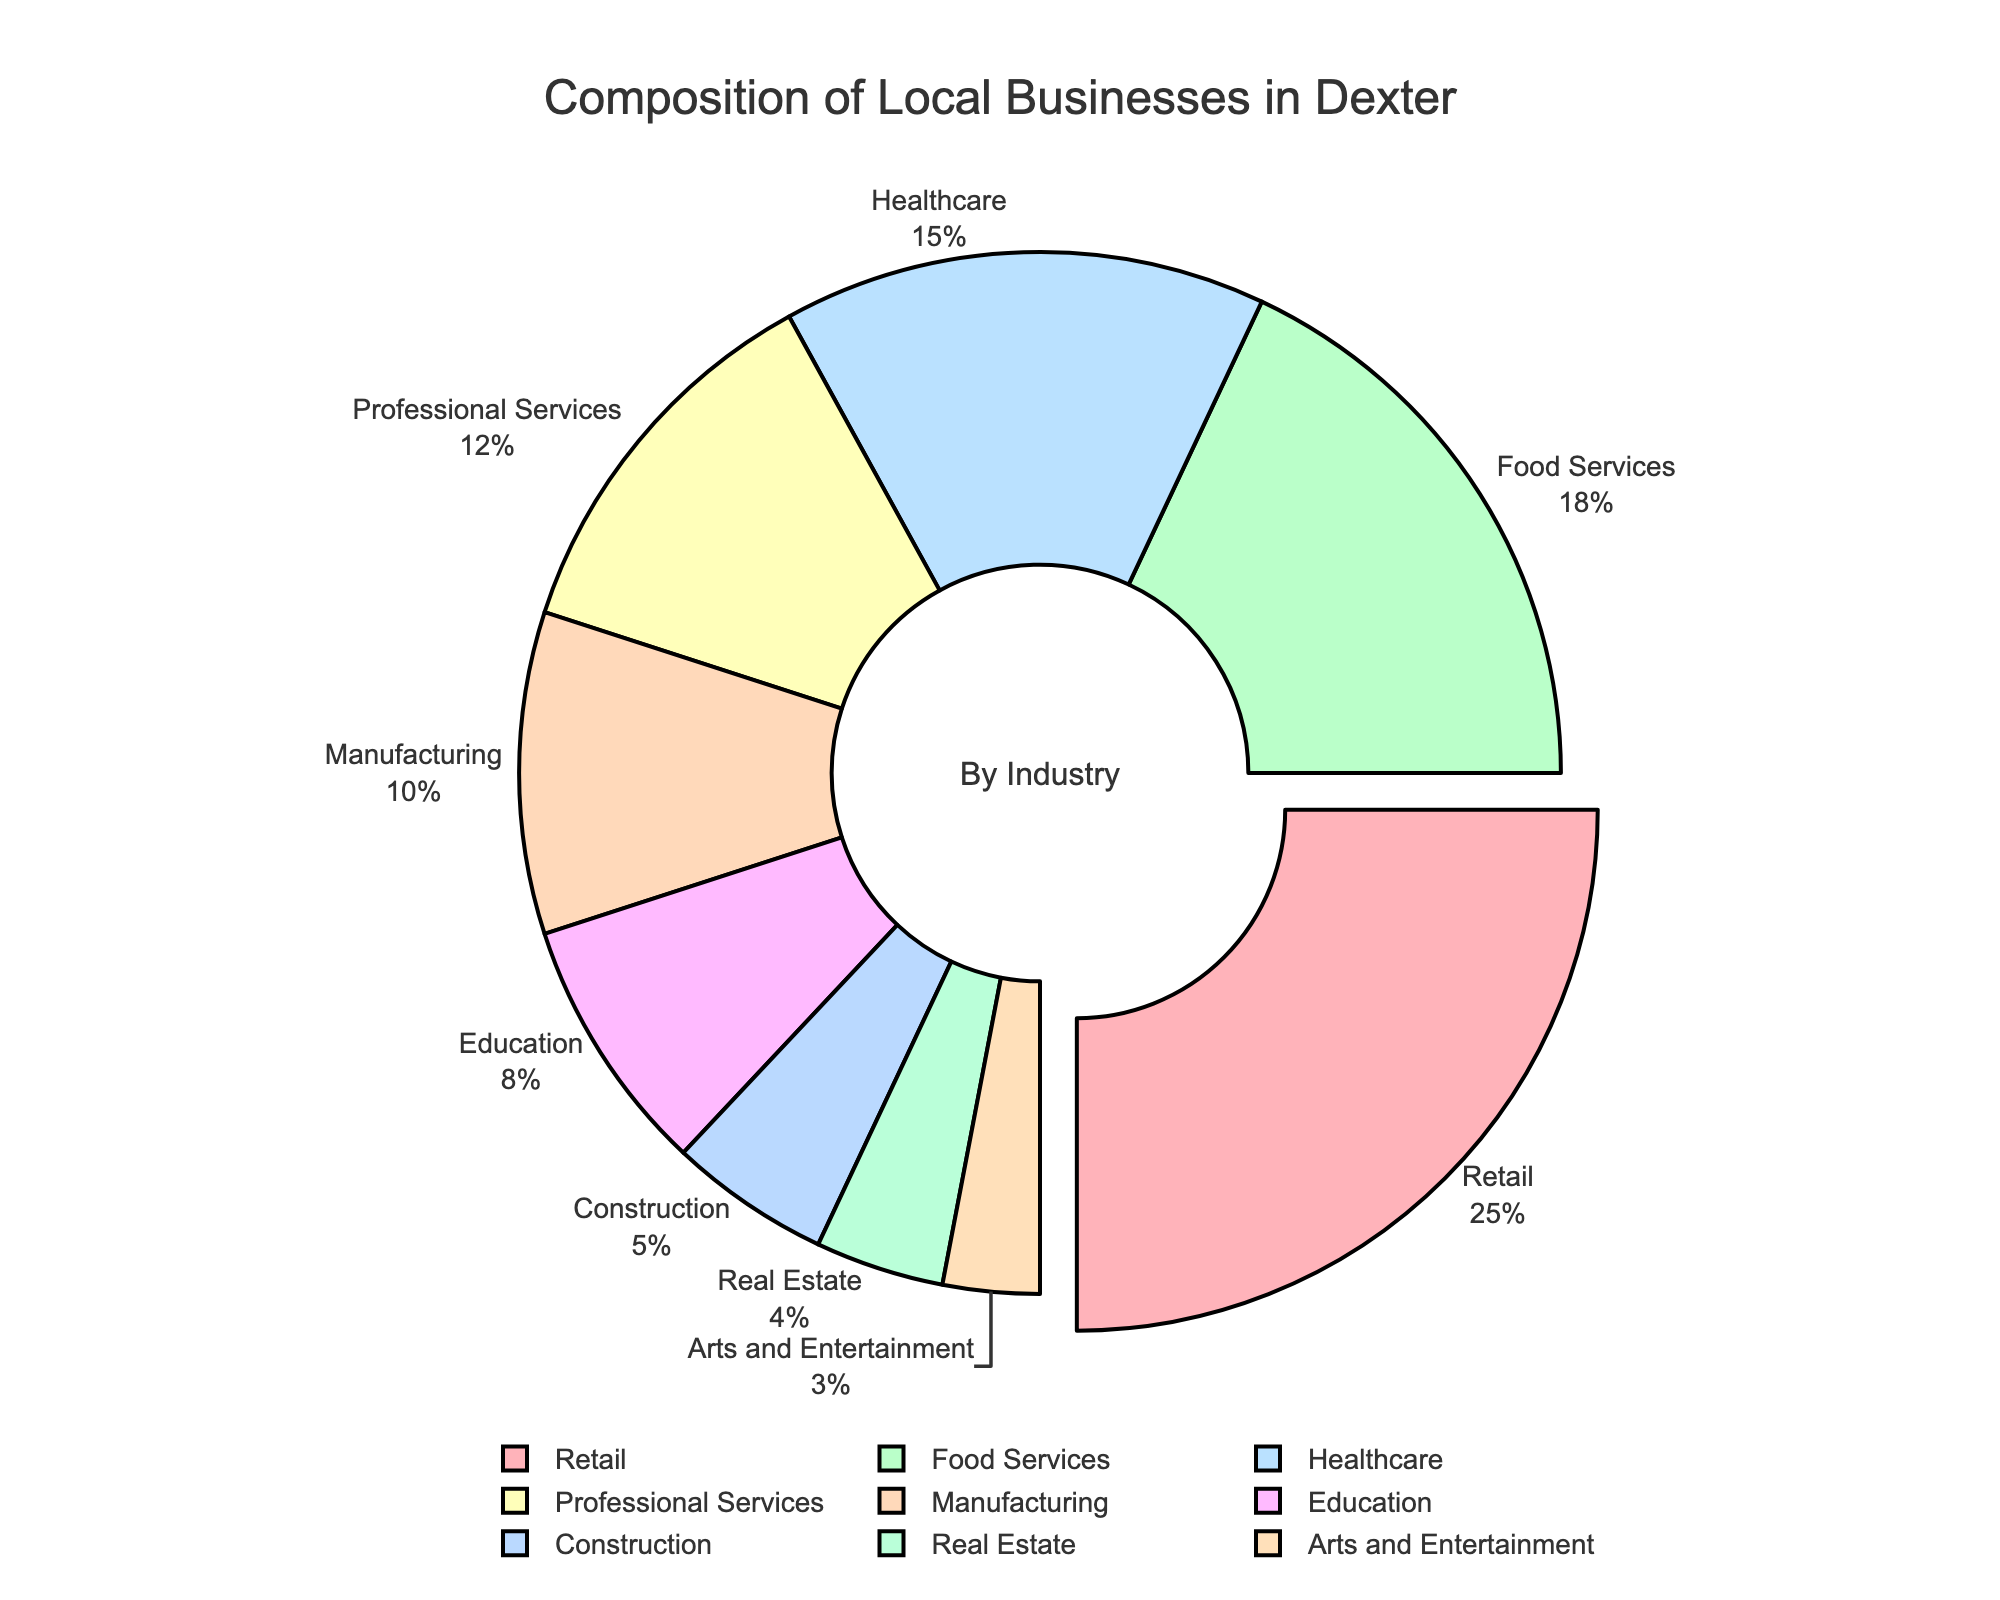What percentage of local businesses in Dexter are in the Retail and Food Services industries combined? Look at the sections of the pie chart labeled "Retail" and "Food Services". The Retail industry makes up 25% of local businesses, and the Food Services industry makes up 18%. Add these percentages together: 25% + 18% = 43%.
Answer: 43% Which industry has the smallest share of local businesses, and what is that percentage? Identify the section of the pie chart with the smallest segment. The smallest segment represents the "Arts and Entertainment" industry, which makes up 3% of local businesses.
Answer: Arts and Entertainment, 3% Is the percentage of businesses in the Education industry greater or less than those in the Professional Services industry? Compare the segments labeled "Education" and "Professional Services" in the pie chart. The Education industry accounts for 8%, while Professional Services account for 12%. Since 8% is less than 12%, the Education industry has a smaller share.
Answer: Less What is the total percentage of businesses in Dexter that fall within the Construction and Real Estate industries? Locate the segments of the pie chart labeled "Construction" and "Real Estate". The Construction industry accounts for 5% and the Real Estate industry accounts for 4%. Add these together: 5% + 4% = 9%.
Answer: 9% What industry has the highest percentage share, and what is that percentage? Identify the largest segment of the pie chart, which represents the industry with the highest percentage. The largest segment corresponds to the "Retail" industry, which makes up 25% of local businesses.
Answer: Retail, 25% Which three industries have the highest percentages of local businesses in Dexter? Examine the pie chart to determine the three largest segments. They correspond to the "Retail" (25%), "Food Services" (18%), and "Healthcare" (15%) industries.
Answer: Retail, Food Services, Healthcare How much larger is the share of the Manufacturing industry compared to the Arts and Entertainment industry? Look at the segments labeled "Manufacturing" and "Arts and Entertainment". The Manufacturing industry makes up 10%, and the Arts and Entertainment industry makes up 3%. Subtract the smaller percentage from the larger percentage: 10% - 3% = 7%.
Answer: 7% What is the average percentage of businesses in the Construction, Real Estate, and Arts and Entertainment industries? Identify and sum the percentages of the "Construction" (5%), "Real Estate" (4%), and "Arts and Entertainment" (3%) industries. The sum is 5% + 4% + 3% = 12%. Divide by 3 to find the average: 12% / 3 = 4%.
Answer: 4% How does the size of the Information Technology segment visually compare to the largest segment? Notice that there is no "Information Technology" segment in the pie chart, so the size comparison is between zero and the largest segment ("Retail", 25%). The IT segment is visually non-existent compared to the largest segment.
Answer: Non-existent 